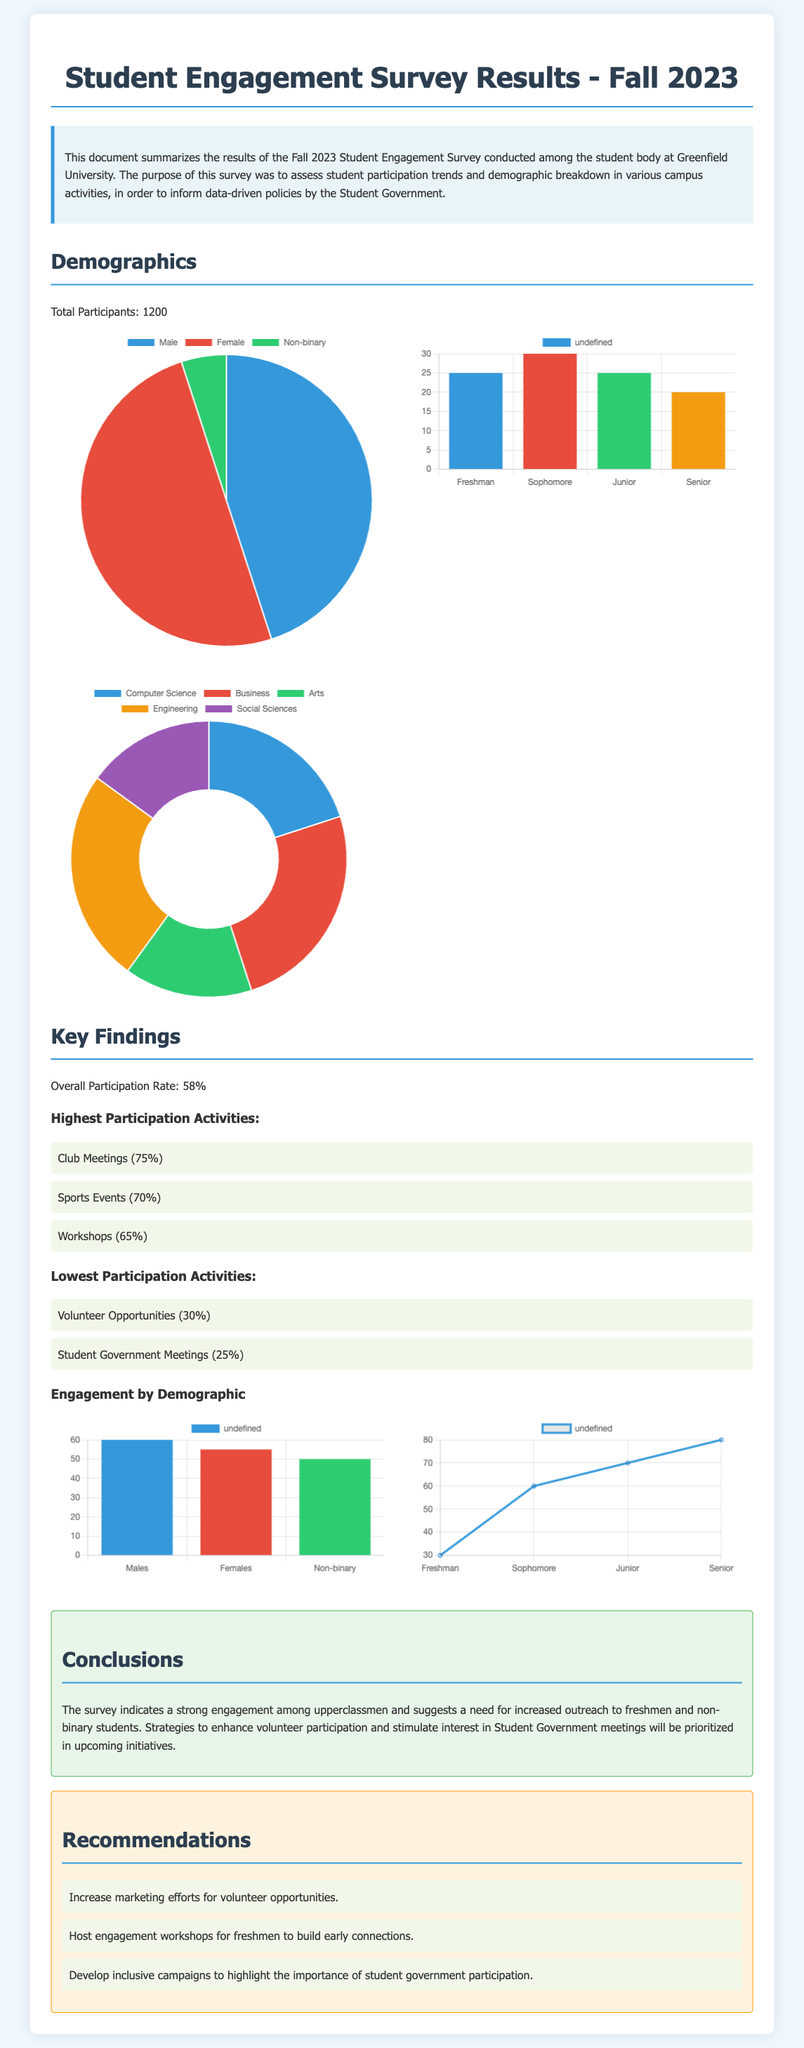What is the total number of participants in the survey? The total number of participants is noted in the demographics section, which states that 1200 students participated.
Answer: 1200 What is the overall participation rate? The overall participation rate is specified in the Key Findings section of the document.
Answer: 58% Which activity had the highest participation rate? The activities with the highest participation are listed under the Highest Participation Activities section.
Answer: Club Meetings What percentage of non-binary students participated? The gender distribution chart indicates that 5% of participants identified as non-binary.
Answer: 5% What is the participation percentage for volunteer opportunities? The participation percentage for volunteer opportunities is illustrated in the Lowest Participation Activities section.
Answer: 30% Which group has the highest engagement percentage according to the engagement by year of study? The engagement data is provided in the engagement section, comparing different years of study.
Answer: Seniors What recommendation is made for freshmen to enhance participation? Recommendations for freshmen can be found in the Recommendations section, emphasizing outreach efforts.
Answer: Host engagement workshops What is the gender distribution percentage for females? The gender distribution chart shows the specific percentage of female participants.
Answer: 50% What was the lowest participation percentage for any activity? The document specifies the lowest participation rates under the Lowest Participation Activities section.
Answer: 25% 